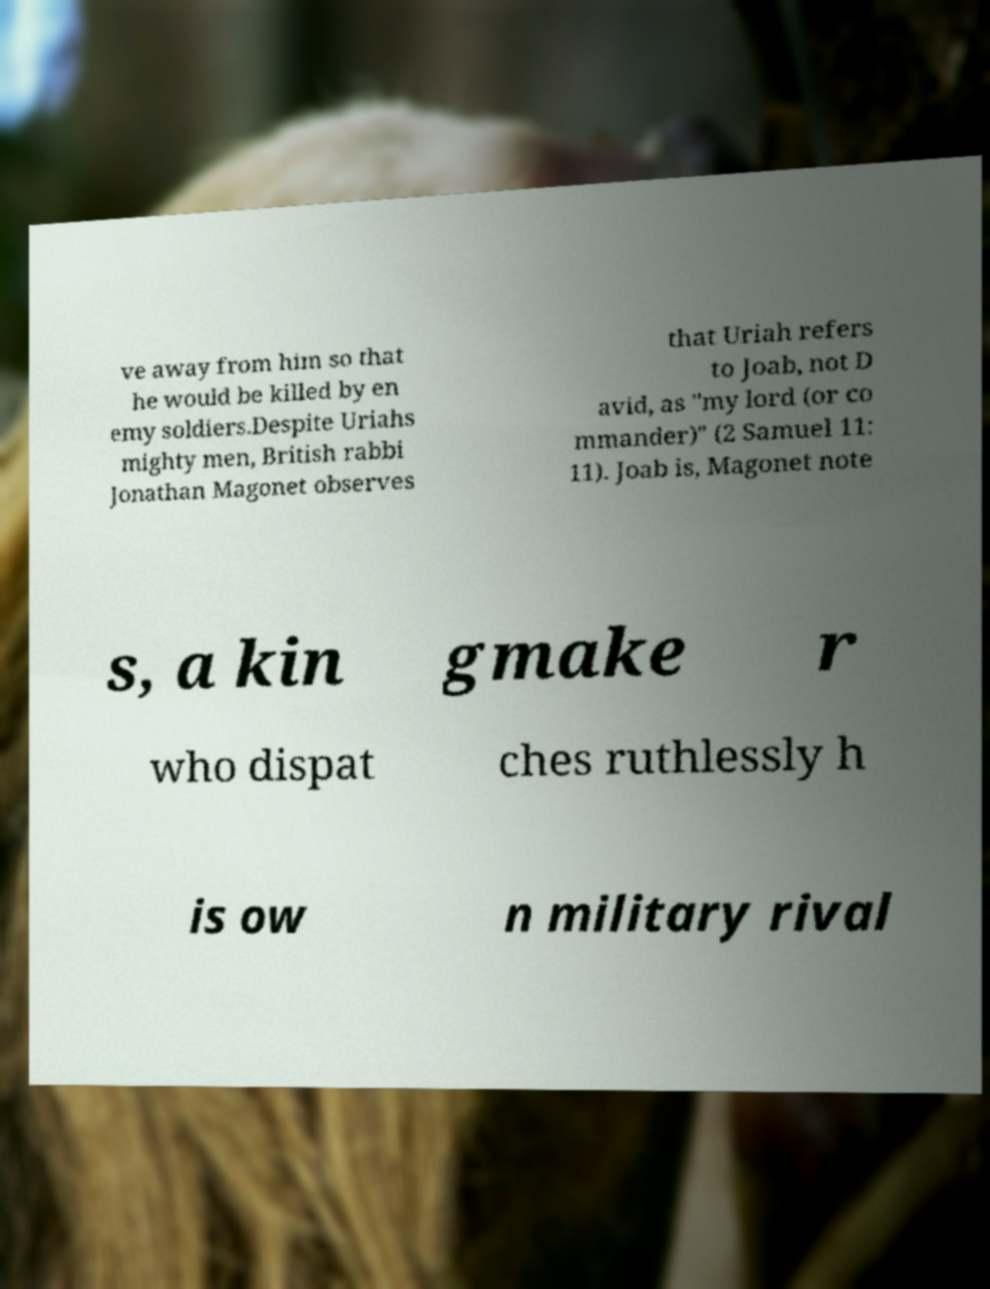What messages or text are displayed in this image? I need them in a readable, typed format. ve away from him so that he would be killed by en emy soldiers.Despite Uriahs mighty men, British rabbi Jonathan Magonet observes that Uriah refers to Joab, not D avid, as "my lord (or co mmander)" (2 Samuel 11: 11). Joab is, Magonet note s, a kin gmake r who dispat ches ruthlessly h is ow n military rival 